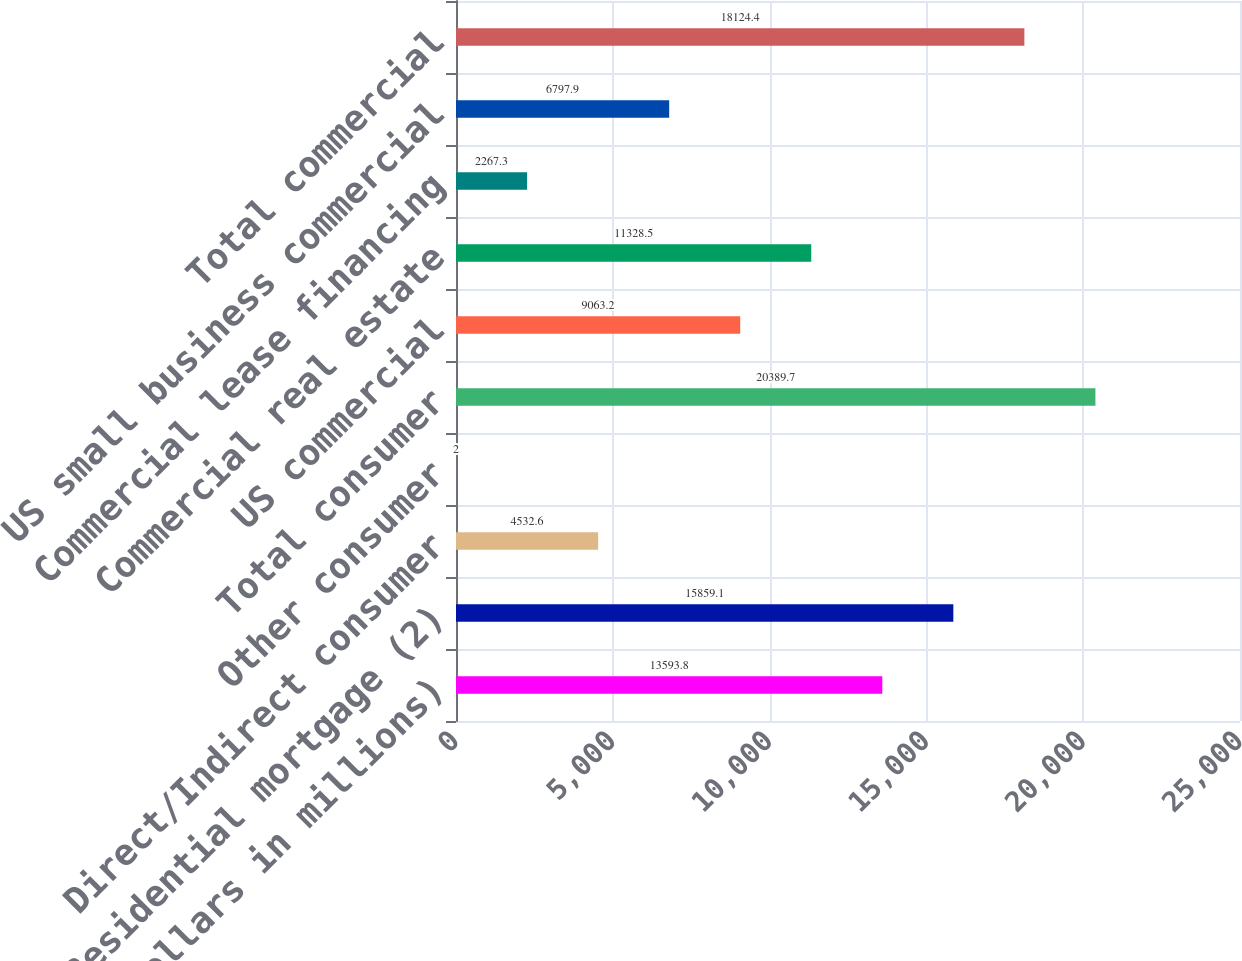Convert chart to OTSL. <chart><loc_0><loc_0><loc_500><loc_500><bar_chart><fcel>(Dollars in millions)<fcel>Residential mortgage (2)<fcel>Direct/Indirect consumer<fcel>Other consumer<fcel>Total consumer<fcel>US commercial<fcel>Commercial real estate<fcel>Commercial lease financing<fcel>US small business commercial<fcel>Total commercial<nl><fcel>13593.8<fcel>15859.1<fcel>4532.6<fcel>2<fcel>20389.7<fcel>9063.2<fcel>11328.5<fcel>2267.3<fcel>6797.9<fcel>18124.4<nl></chart> 